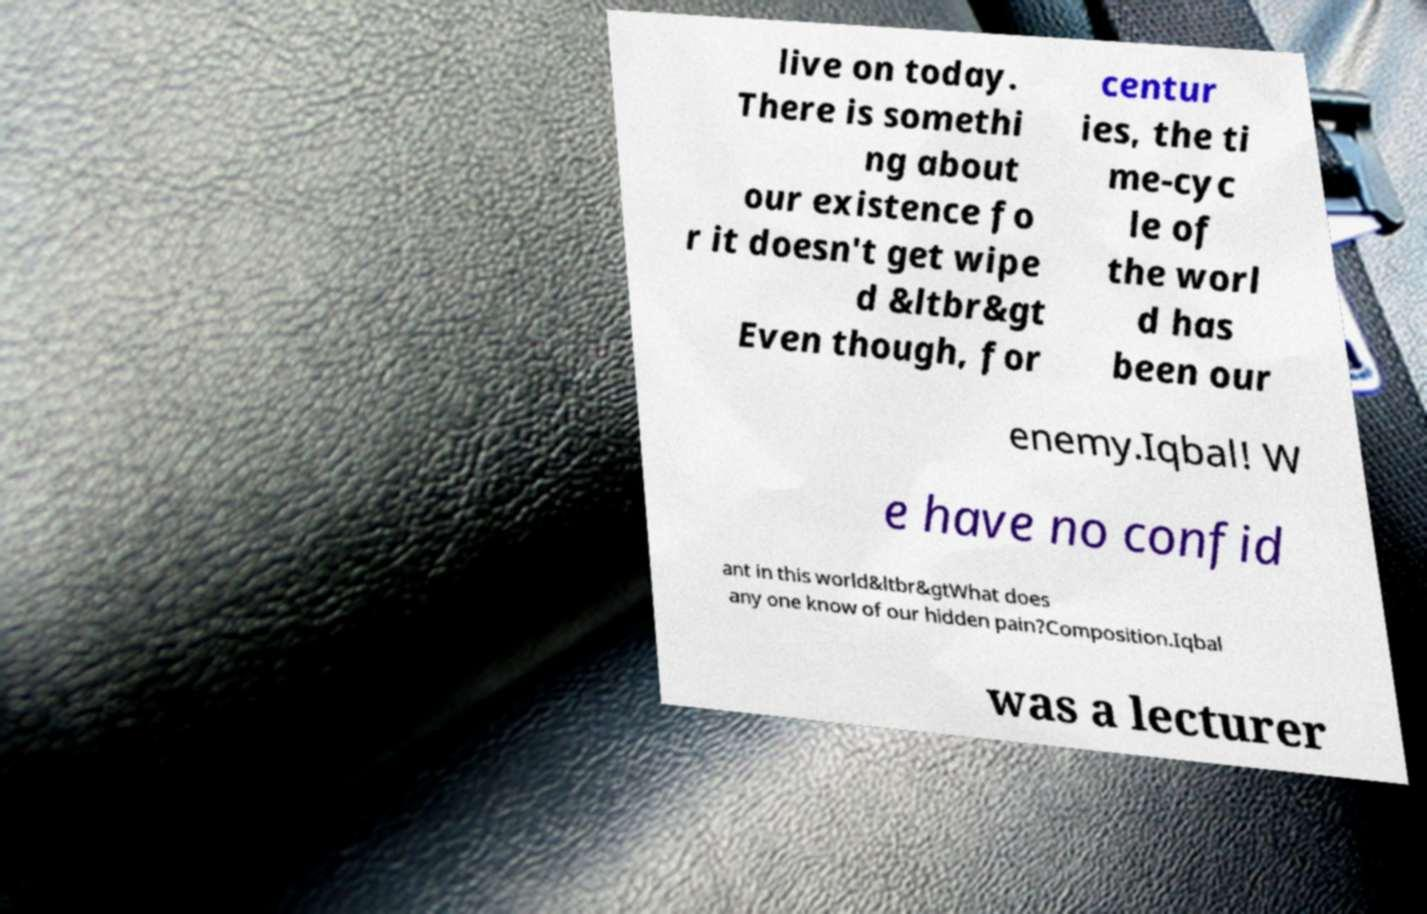Can you read and provide the text displayed in the image?This photo seems to have some interesting text. Can you extract and type it out for me? live on today. There is somethi ng about our existence fo r it doesn't get wipe d &ltbr&gt Even though, for centur ies, the ti me-cyc le of the worl d has been our enemy.Iqbal! W e have no confid ant in this world&ltbr&gtWhat does any one know of our hidden pain?Composition.Iqbal was a lecturer 